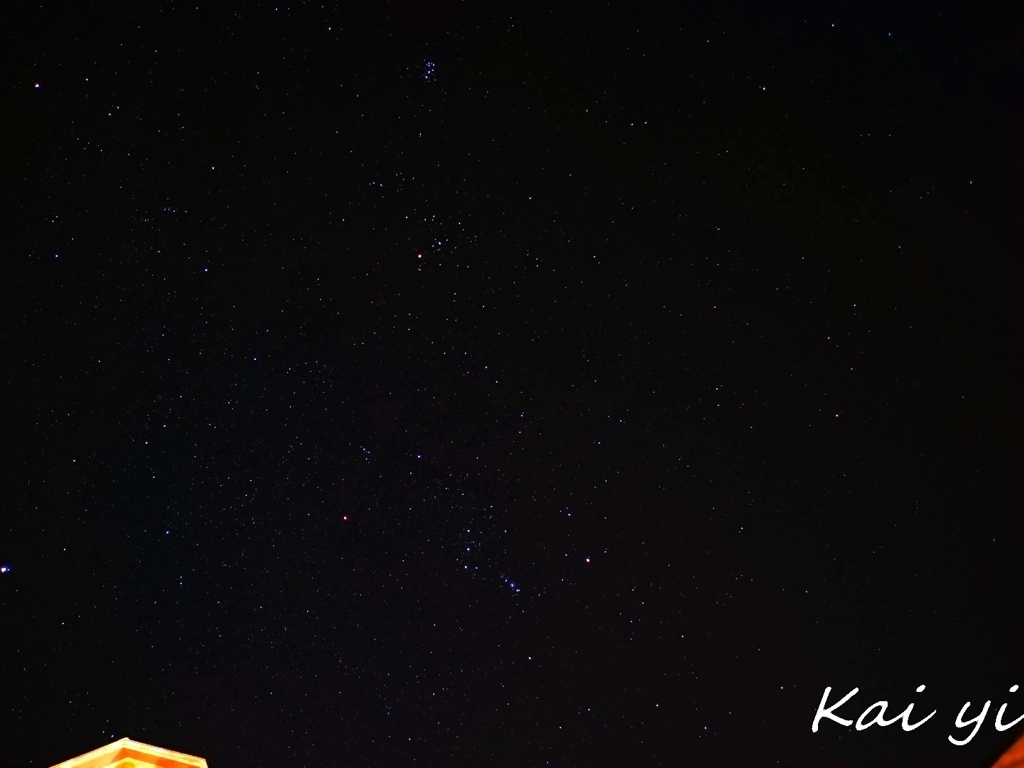Can you identify any constellations in this night sky image? While specific stars can be pinpointed, accurately identifying constellations can be challenging without more context or a star map aligned to the image. However, if we assume the brighter stars form a part of a constellation, we could make an educated guess or use star pattern recognition to attempt a match. 